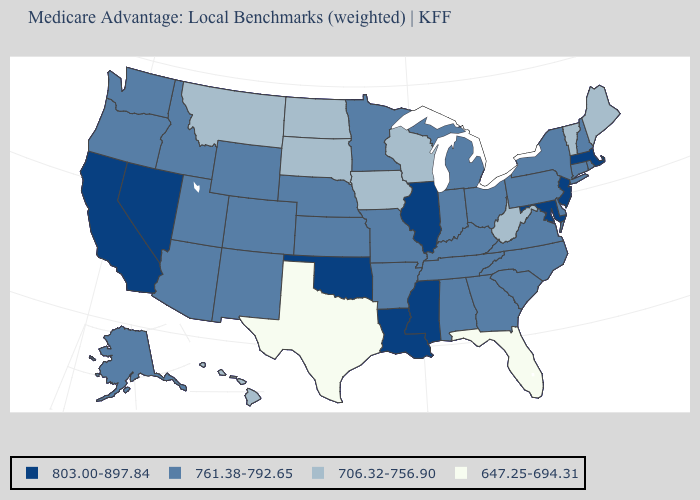Does Texas have the lowest value in the South?
Short answer required. Yes. What is the value of North Carolina?
Concise answer only. 761.38-792.65. What is the value of Nebraska?
Quick response, please. 761.38-792.65. Does the first symbol in the legend represent the smallest category?
Short answer required. No. What is the value of Wisconsin?
Be succinct. 706.32-756.90. Does the first symbol in the legend represent the smallest category?
Give a very brief answer. No. What is the highest value in the South ?
Answer briefly. 803.00-897.84. Is the legend a continuous bar?
Write a very short answer. No. Name the states that have a value in the range 803.00-897.84?
Be succinct. California, Illinois, Louisiana, Massachusetts, Maryland, Mississippi, New Jersey, Nevada, Oklahoma. What is the value of Oregon?
Short answer required. 761.38-792.65. What is the value of Indiana?
Give a very brief answer. 761.38-792.65. Name the states that have a value in the range 803.00-897.84?
Quick response, please. California, Illinois, Louisiana, Massachusetts, Maryland, Mississippi, New Jersey, Nevada, Oklahoma. How many symbols are there in the legend?
Concise answer only. 4. Does North Carolina have a higher value than Montana?
Write a very short answer. Yes. Does New York have the same value as Massachusetts?
Quick response, please. No. 